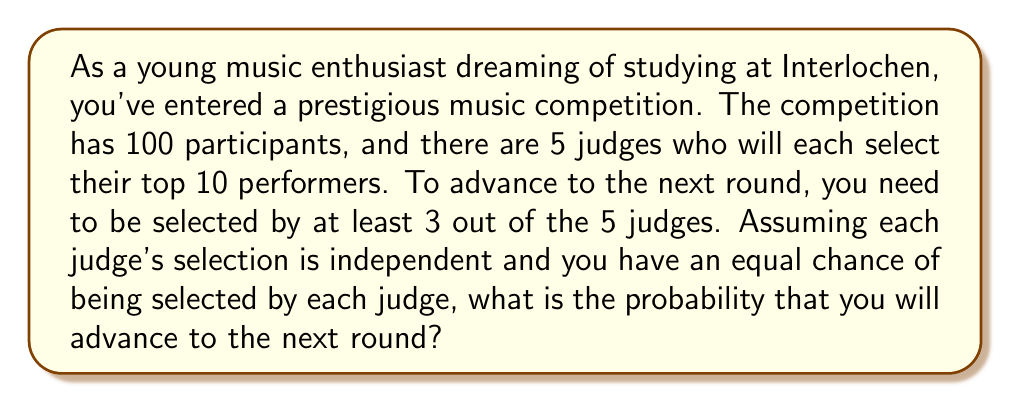Could you help me with this problem? Let's approach this step-by-step:

1) First, we need to calculate the probability of being selected by a single judge. Since each judge selects 10 out of 100 participants, this probability is:

   $P(\text{selected by one judge}) = \frac{10}{100} = 0.1$

2) Now, we need to find the probability of being selected by at least 3 out of 5 judges. This can happen in three ways:
   - Selected by exactly 3 judges
   - Selected by exactly 4 judges
   - Selected by all 5 judges

3) We can use the binomial probability formula to calculate each of these:

   $P(X = k) = \binom{n}{k} p^k (1-p)^{n-k}$

   Where $n = 5$ (total judges), $p = 0.1$ (probability of being selected by one judge), and $k$ is the number of judges selecting you.

4) Calculating each probability:

   $P(\text{3 judges}) = \binom{5}{3} (0.1)^3 (0.9)^2 = 10 \times 0.001 \times 0.81 = 0.0081$

   $P(\text{4 judges}) = \binom{5}{4} (0.1)^4 (0.9)^1 = 5 \times 0.0001 \times 0.9 = 0.00045$

   $P(\text{5 judges}) = \binom{5}{5} (0.1)^5 (0.9)^0 = 1 \times 0.00001 \times 1 = 0.00001$

5) The total probability is the sum of these individual probabilities:

   $P(\text{at least 3 judges}) = 0.0081 + 0.00045 + 0.00001 = 0.00856$
Answer: The probability of advancing to the next round is approximately 0.00856 or 0.856%. 